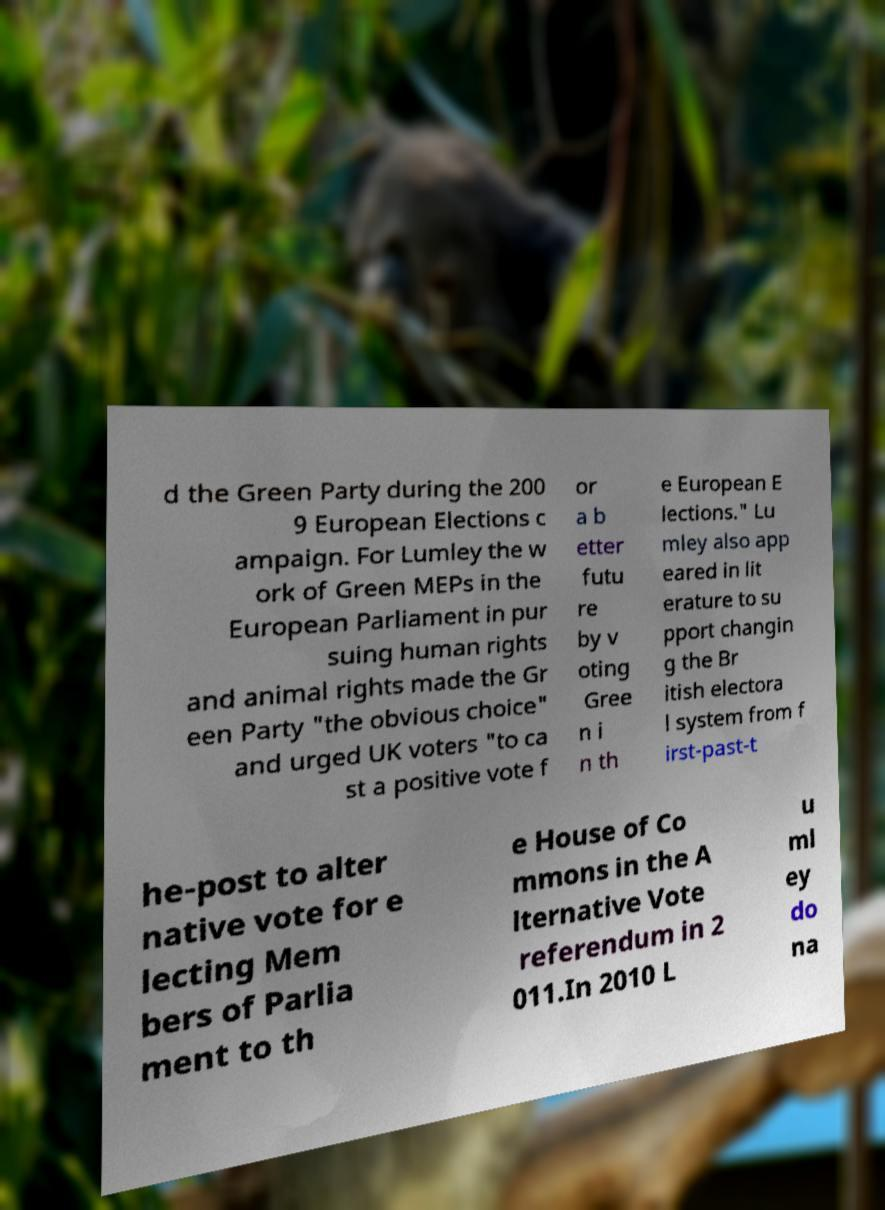I need the written content from this picture converted into text. Can you do that? d the Green Party during the 200 9 European Elections c ampaign. For Lumley the w ork of Green MEPs in the European Parliament in pur suing human rights and animal rights made the Gr een Party "the obvious choice" and urged UK voters "to ca st a positive vote f or a b etter futu re by v oting Gree n i n th e European E lections." Lu mley also app eared in lit erature to su pport changin g the Br itish electora l system from f irst-past-t he-post to alter native vote for e lecting Mem bers of Parlia ment to th e House of Co mmons in the A lternative Vote referendum in 2 011.In 2010 L u ml ey do na 